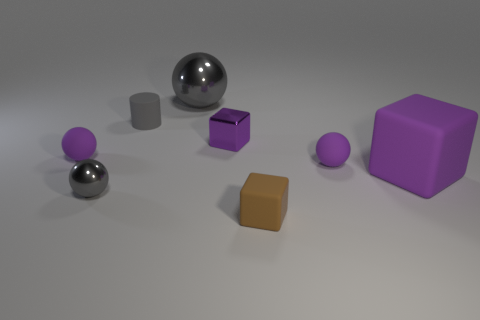Subtract all tiny blocks. How many blocks are left? 1 Subtract all brown cubes. How many cubes are left? 2 Subtract all small blue cylinders. Subtract all tiny matte blocks. How many objects are left? 7 Add 5 small gray metallic spheres. How many small gray metallic spheres are left? 6 Add 5 purple matte blocks. How many purple matte blocks exist? 6 Add 1 yellow matte cubes. How many objects exist? 9 Subtract 0 blue balls. How many objects are left? 8 Subtract all cubes. How many objects are left? 5 Subtract 1 cylinders. How many cylinders are left? 0 Subtract all yellow cubes. Subtract all gray cylinders. How many cubes are left? 3 